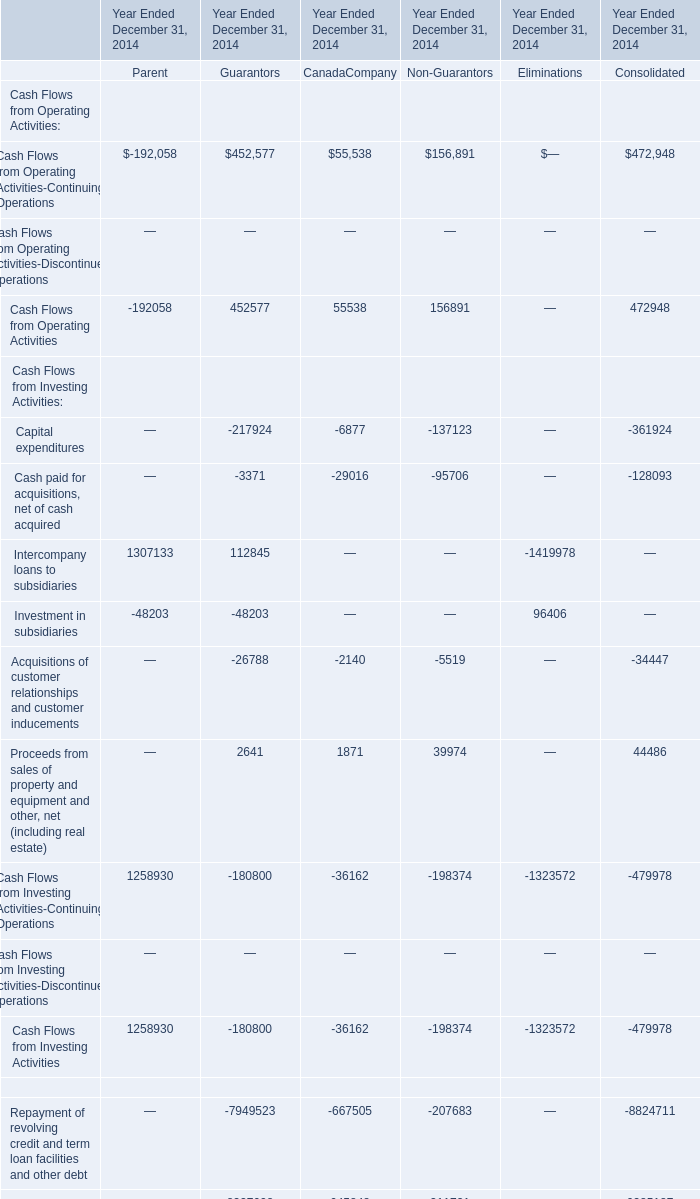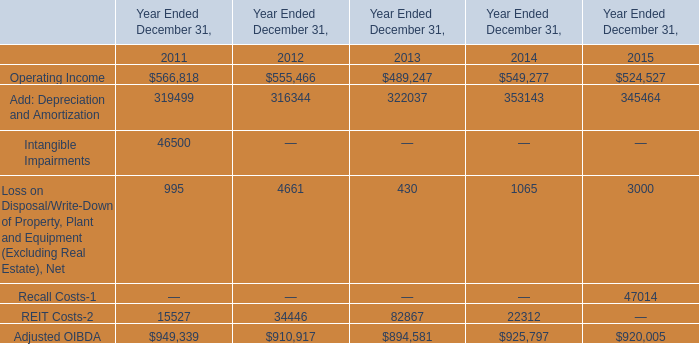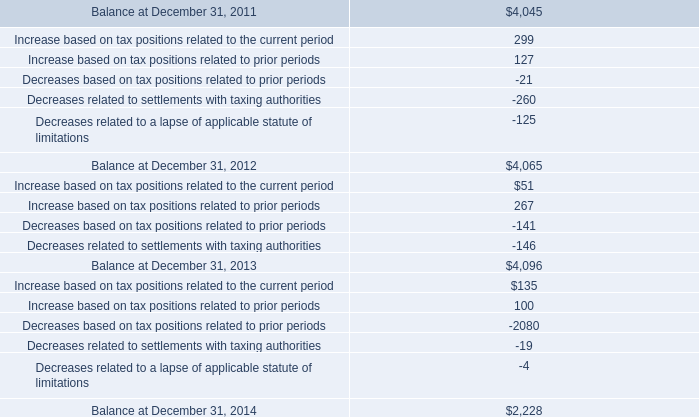Which CanadaCompany occupies the greatest proportion in total amount in 2014? 
Answer: Proceeds from revolving credit and term loan facilities and other debt. 